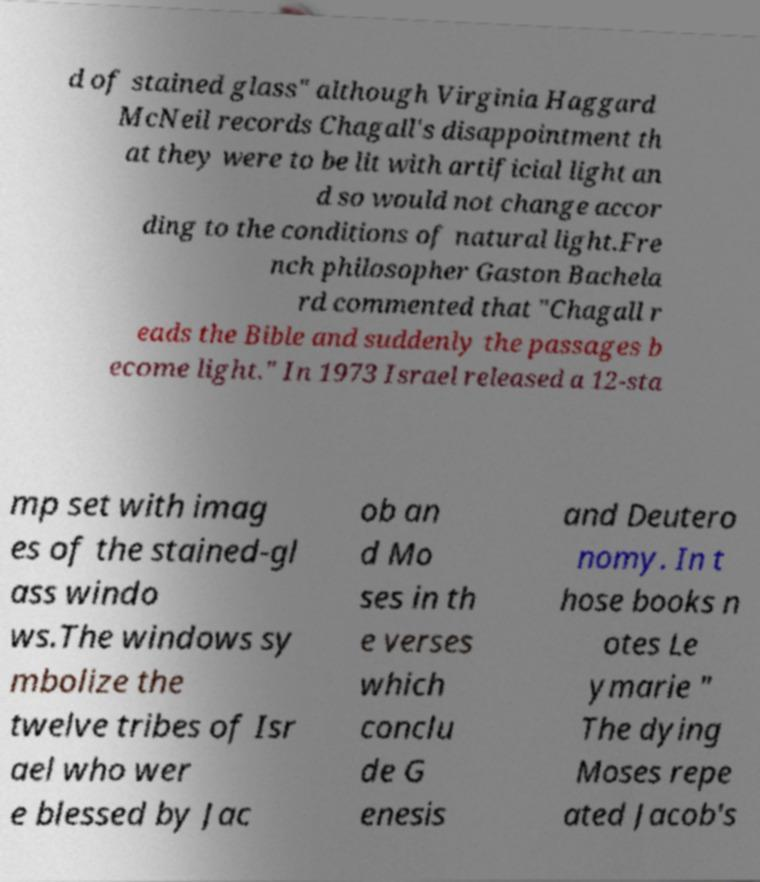What messages or text are displayed in this image? I need them in a readable, typed format. d of stained glass" although Virginia Haggard McNeil records Chagall's disappointment th at they were to be lit with artificial light an d so would not change accor ding to the conditions of natural light.Fre nch philosopher Gaston Bachela rd commented that "Chagall r eads the Bible and suddenly the passages b ecome light." In 1973 Israel released a 12-sta mp set with imag es of the stained-gl ass windo ws.The windows sy mbolize the twelve tribes of Isr ael who wer e blessed by Jac ob an d Mo ses in th e verses which conclu de G enesis and Deutero nomy. In t hose books n otes Le ymarie " The dying Moses repe ated Jacob's 